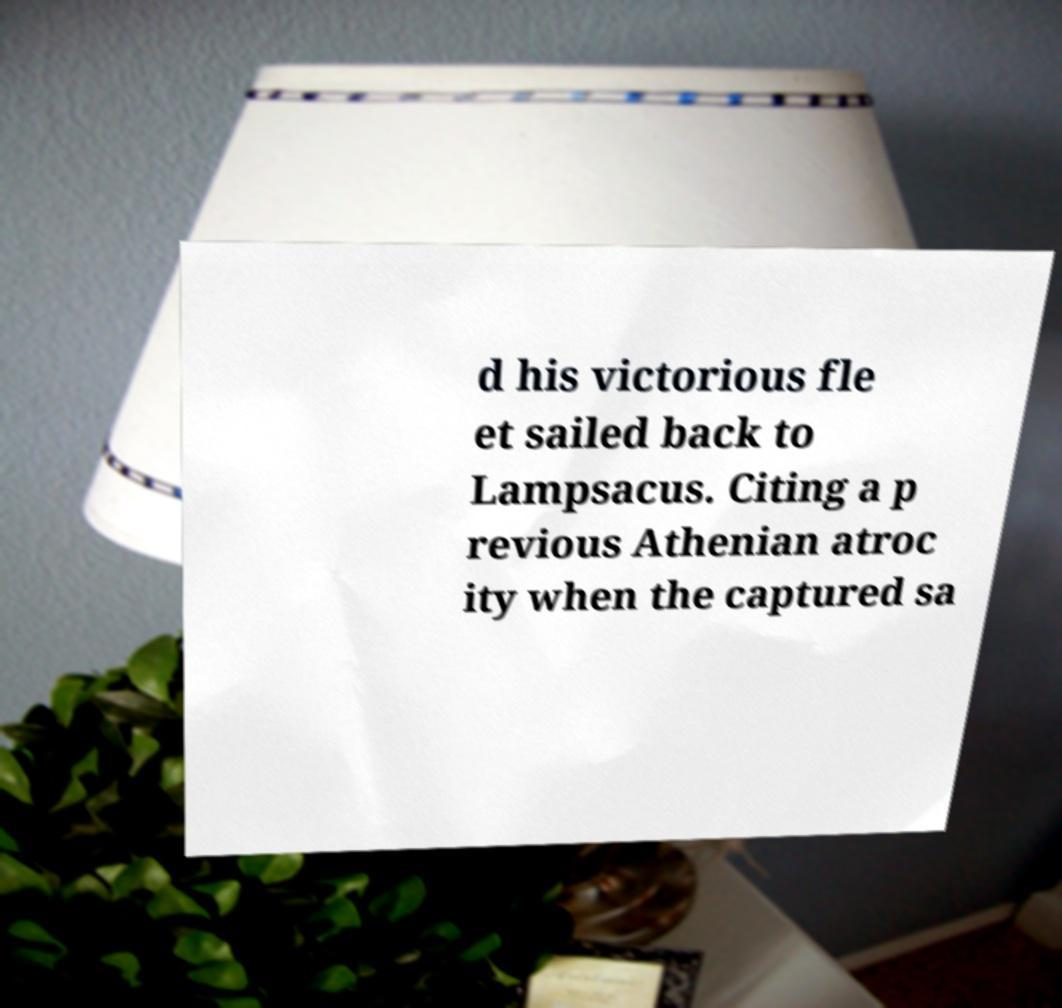Please identify and transcribe the text found in this image. d his victorious fle et sailed back to Lampsacus. Citing a p revious Athenian atroc ity when the captured sa 